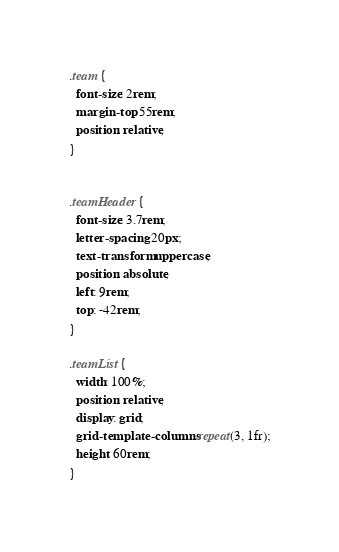<code> <loc_0><loc_0><loc_500><loc_500><_CSS_>.team {
  font-size: 2rem;
  margin-top: 55rem;
  position: relative;
}


.teamHeader {
  font-size: 3.7rem;
  letter-spacing: 20px;
  text-transform: uppercase;
  position: absolute;
  left: 9rem;
  top: -42rem;
}

.teamList {
  width: 100%;
  position: relative;
  display: grid;
  grid-template-columns: repeat(3, 1fr);
  height: 60rem;
}

</code> 